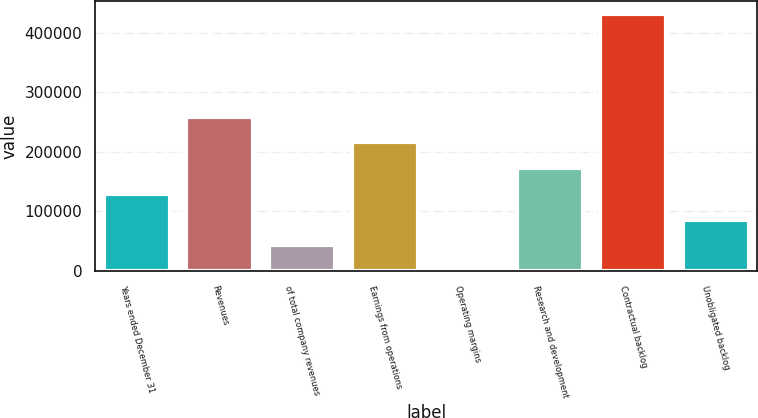Convert chart to OTSL. <chart><loc_0><loc_0><loc_500><loc_500><bar_chart><fcel>Years ended December 31<fcel>Revenues<fcel>of total company revenues<fcel>Earnings from operations<fcel>Operating margins<fcel>Research and development<fcel>Contractual backlog<fcel>Unobligated backlog<nl><fcel>129428<fcel>258848<fcel>43147.8<fcel>215708<fcel>7.8<fcel>172568<fcel>431408<fcel>86287.8<nl></chart> 